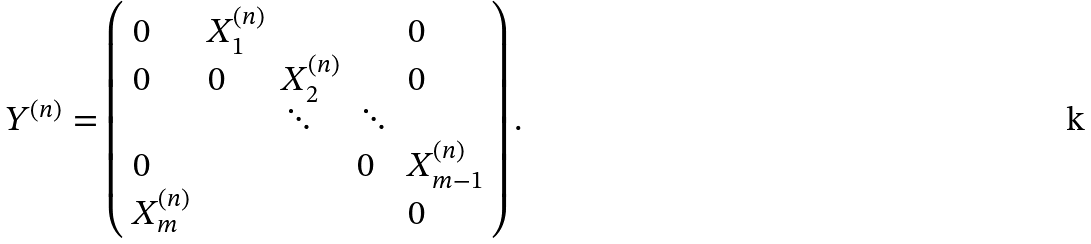Convert formula to latex. <formula><loc_0><loc_0><loc_500><loc_500>Y ^ { ( n ) } = \left ( \begin{array} { l l l l l c } 0 & X ^ { ( n ) } _ { 1 } & & & 0 \\ 0 & 0 & X ^ { ( n ) } _ { 2 } & & 0 \\ & & \ddots & \ddots & \\ 0 & & & 0 & X ^ { ( n ) } _ { m - 1 } \\ X ^ { ( n ) } _ { m } & & & & 0 \end{array} \right ) .</formula> 